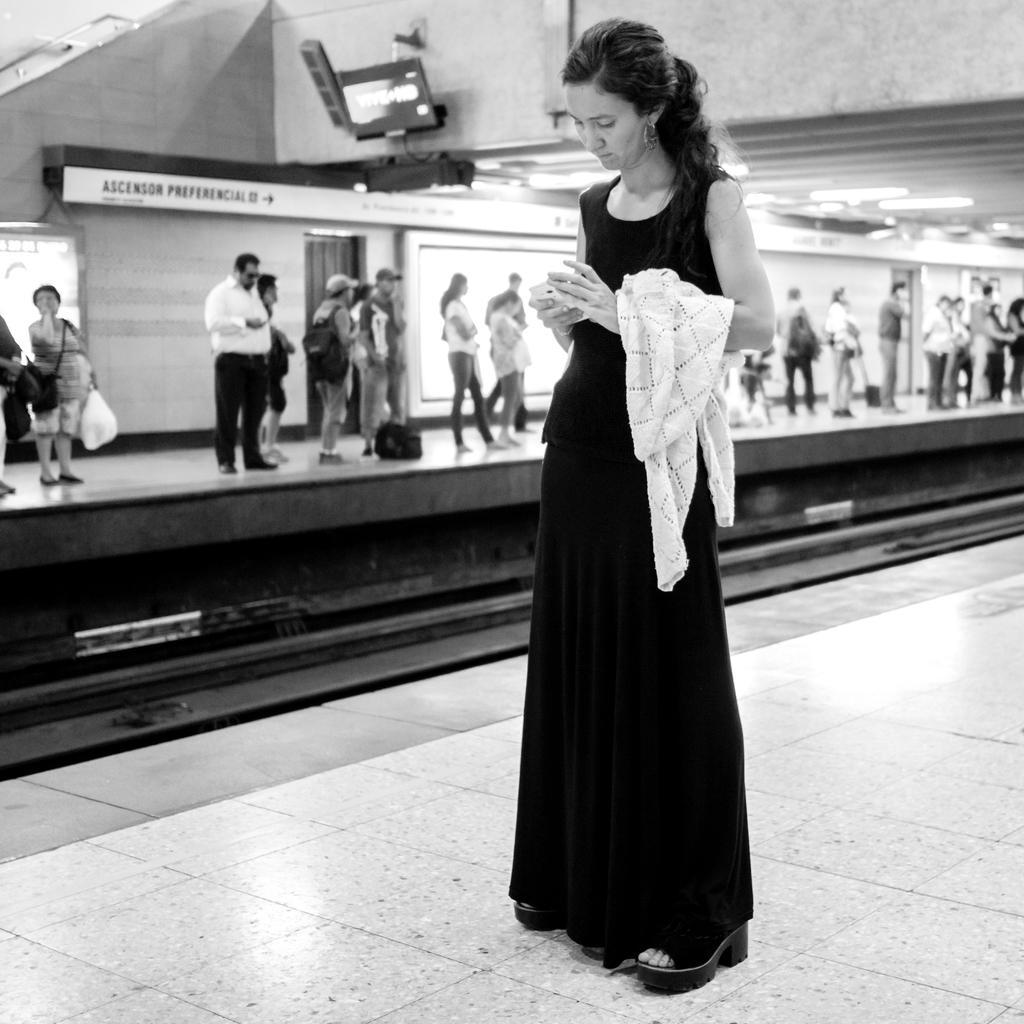How would you summarize this image in a sentence or two? In this image we can see a few people standing, we can see the railway track, platform, ceiling with lights, some text written on the wall. 